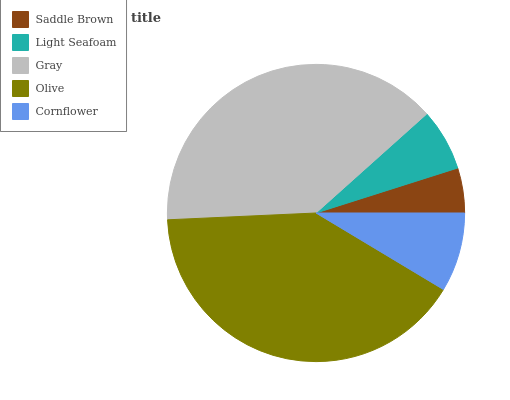Is Saddle Brown the minimum?
Answer yes or no. Yes. Is Olive the maximum?
Answer yes or no. Yes. Is Light Seafoam the minimum?
Answer yes or no. No. Is Light Seafoam the maximum?
Answer yes or no. No. Is Light Seafoam greater than Saddle Brown?
Answer yes or no. Yes. Is Saddle Brown less than Light Seafoam?
Answer yes or no. Yes. Is Saddle Brown greater than Light Seafoam?
Answer yes or no. No. Is Light Seafoam less than Saddle Brown?
Answer yes or no. No. Is Cornflower the high median?
Answer yes or no. Yes. Is Cornflower the low median?
Answer yes or no. Yes. Is Gray the high median?
Answer yes or no. No. Is Olive the low median?
Answer yes or no. No. 